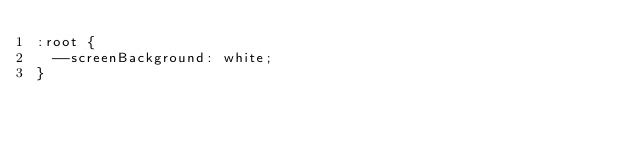Convert code to text. <code><loc_0><loc_0><loc_500><loc_500><_CSS_>:root {
  --screenBackground: white;
}</code> 